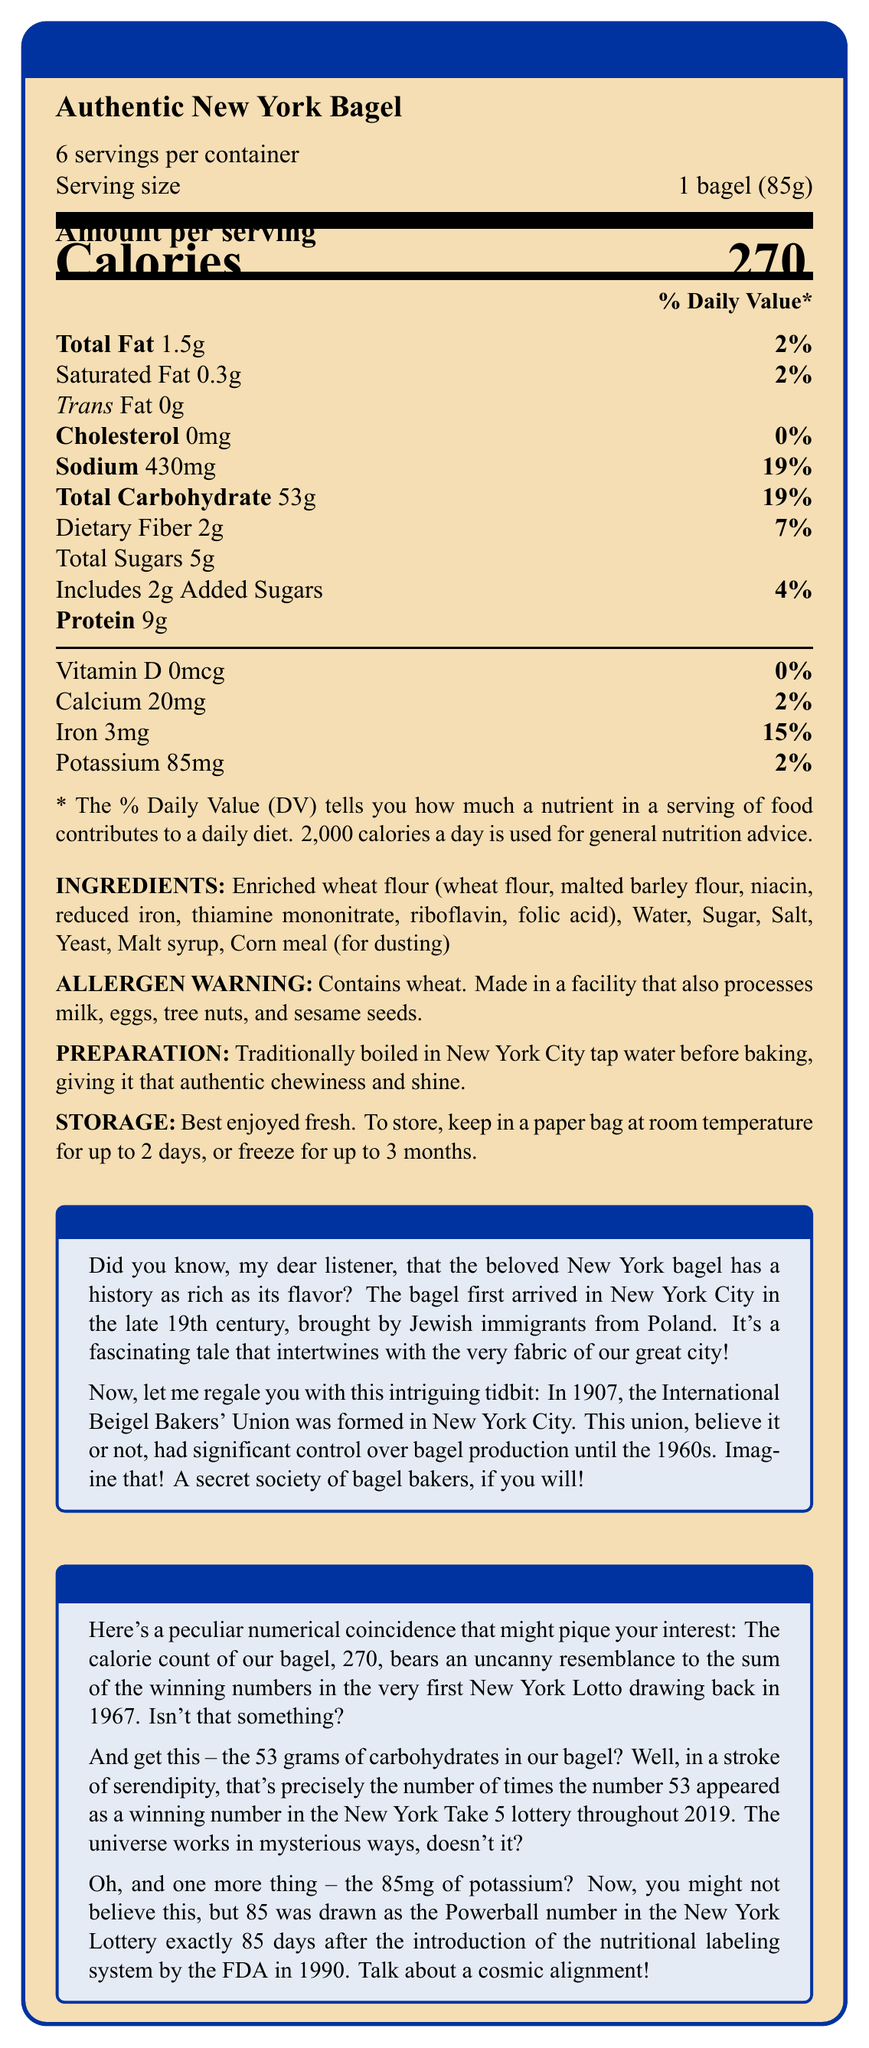what is the serving size? The serving size is explicitly stated as "1 bagel (85g)" in the document.
Answer: 1 bagel (85g) how many calories are in one serving? The document states that the amount per serving is 270 calories.
Answer: 270 calories what is the total fat content per serving? The document lists "Total Fat" as 1.5g per serving.
Answer: 1.5g how much iron does one serving contain? The amount of iron per serving is stated as 3mg in the document.
Answer: 3mg how much sodium is in one serving? The sodium content per serving is listed as 430mg.
Answer: 430mg how many grams of carbohydrates are in one bagel? A. 19g B. 53g C. 85g The document states that the "Total Carbohydrate" per serving is 53g.
Answer: B what is the % Daily Value of protein per serving? A. 0% B. 2% C. 15% D. Not provided The % Daily Value of protein is not provided in the document.
Answer: D which of the following is NOT in the ingredients list? A. Enriched wheat flour B. Salt C. Potassium D. Sugar Potassium is not listed among the ingredients; it's listed in the nutritional content.
Answer: C are there any allergens in this product? The document has an allergen warning that the product contains wheat and is made in a facility that also processes milk, eggs, tree nuts, and sesame seeds.
Answer: Yes is there any trans fat in this bagel? The document states there is 0g of trans fat per serving.
Answer: No summarize the main points of this document. The Nutrition Facts Label details nutritional content, ingredients, allergens, preparation, storage, historical trivia, and numerical coincidences related to local lotteries.
Answer: The document is a Nutrition Facts Label for an "Authentic New York Bagel." It provides nutritional information per serving (1 bagel, 85g), including calories, fat, cholesterol, sodium, carbohydrates, proteins, and various vitamins and minerals. Additionally, the document lists the ingredients, allergens, preparation method, and storage instructions. It also includes historical trivia about bagels in New York and some intriguing lottery-related numerical coincidences. when was the International Beigel Bakers' Union formed? The historical trivia section mentions that the International Beigel Bakers' Union was formed in 1907.
Answer: 1907 how is the bagel traditionally prepared? The preparation method states that the bagel is traditionally boiled in New York City tap water before baking.
Answer: Boiled in New York City tap water before baking what is the storage instruction for this bagel? The document gives detailed storage instructions for the bagel.
Answer: Best enjoyed fresh; keep in a paper bag at room temperature for up to 2 days, or freeze for up to 3 months what is the correlation between the calories in the bagel and New York Lotto? This peculiar numerical coincidence is highlighted under the "Lottery Coincidences" section of the document.
Answer: The calorie count of the bagel (270) resembles the sum of the winning numbers in the very first New York Lotto drawing in 1967. how many days after the introduction of nutritional labeling by the FDA in 1990 did the number 85 (mg of potassium) get drawn as the Powerball number in New York Lottery? The document states that the number 85 was drawn as the Powerball number exactly 85 days after the introduction of the nutritional labeling system by the FDA in 1990.
Answer: 85 days how many servings are in one container? The document clearly states that there are 6 servings per container.
Answer: 6 servings what is the historical significance of the number 53 in relation to the bagel's carbohydrates? This numerical coincidence is highlighted in the "Lottery Coincidences" section of the document.
Answer: The 53 grams of carbohydrates is the same number of times the number 53 appeared as a winning number in the New York Take 5 lottery in 2019. what year did the first Jewish immigrants bring the bagel to New York City? The document mentions the late 19th century but does not specify a particular year.
Answer: Cannot be determined 